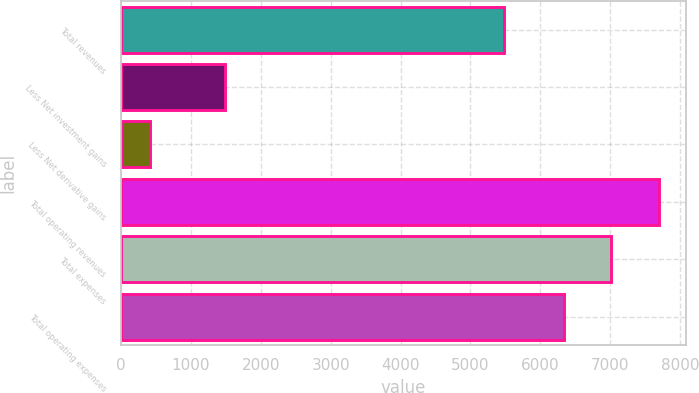Convert chart to OTSL. <chart><loc_0><loc_0><loc_500><loc_500><bar_chart><fcel>Total revenues<fcel>Less Net investment gains<fcel>Less Net derivative gains<fcel>Total operating revenues<fcel>Total expenses<fcel>Total operating expenses<nl><fcel>5486<fcel>1486<fcel>421<fcel>7693.8<fcel>7015.4<fcel>6337<nl></chart> 